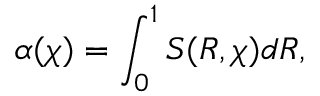Convert formula to latex. <formula><loc_0><loc_0><loc_500><loc_500>\alpha ( \chi ) = \int _ { 0 } ^ { 1 } S ( R , \chi ) d R ,</formula> 